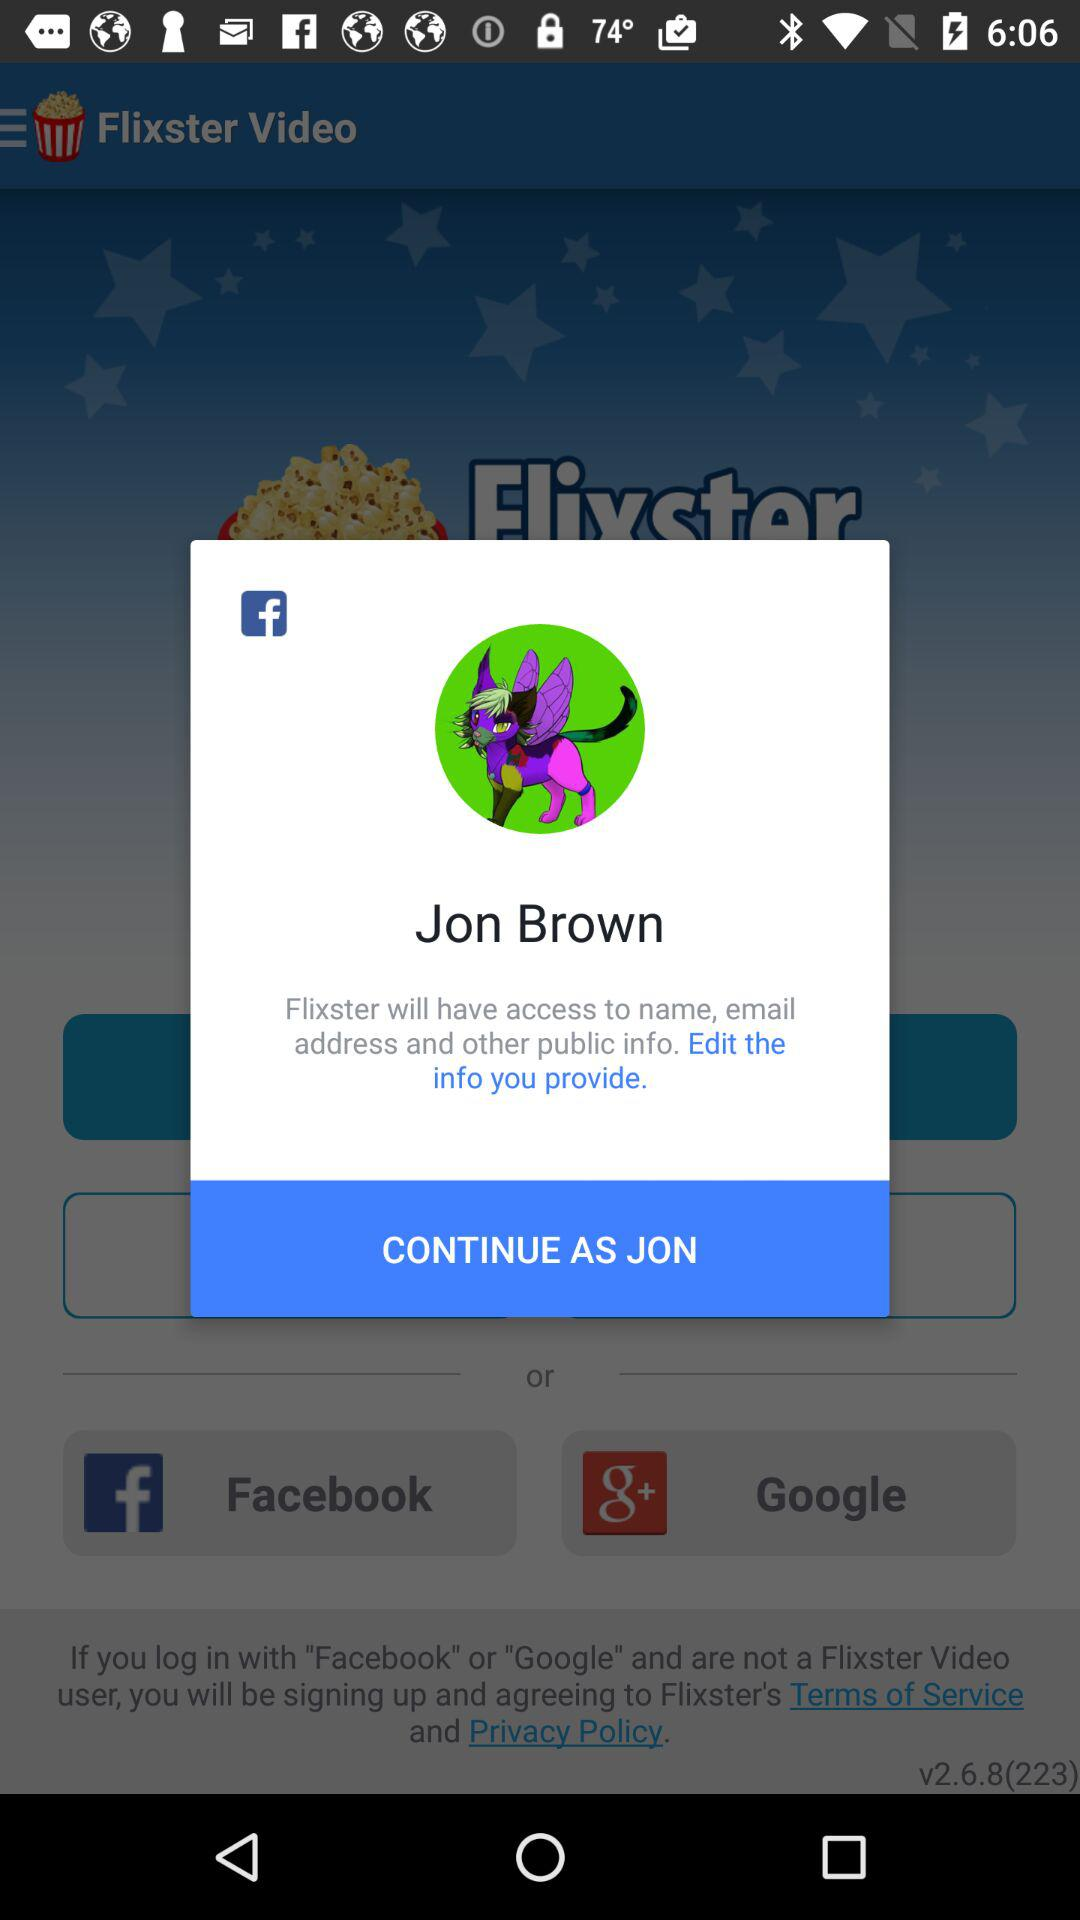What is the user name? The user name is Jon Brown. 